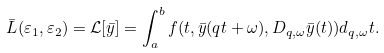Convert formula to latex. <formula><loc_0><loc_0><loc_500><loc_500>\bar { L } ( \varepsilon _ { 1 } , \varepsilon _ { 2 } ) = \mathcal { L } [ \bar { y } ] = \int _ { a } ^ { b } f ( t , \bar { y } ( q t + \omega ) , D _ { q , \omega } \bar { y } ( t ) ) d _ { q , \omega } t .</formula> 